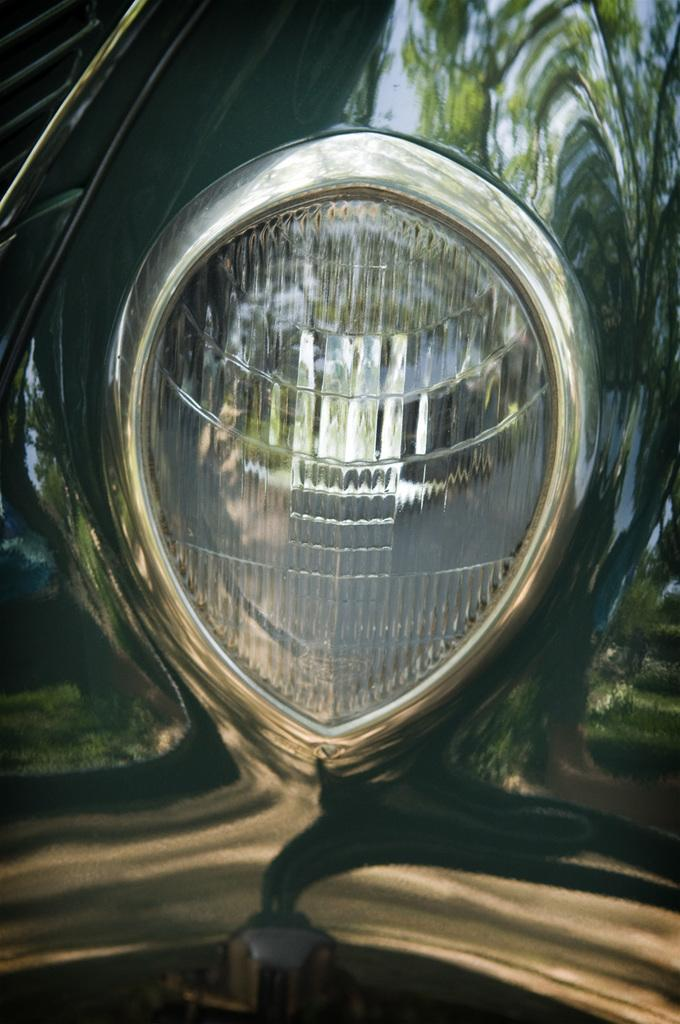What part of a car is visible in the image? There is a front light of a car in the image. Can you describe the location of the front light in relation to the car? The front light is located at the front of the car. What might the front light be used for? The front light is likely used for illuminating the road ahead while driving at night or in low-light conditions. What type of brain can be seen inside the car in the image? There is no brain visible in the image, as it features only the front light of a car. 